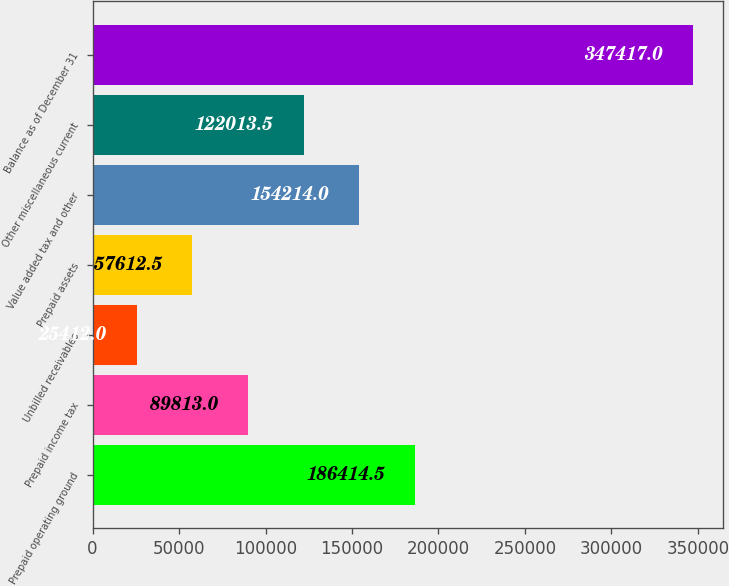Convert chart. <chart><loc_0><loc_0><loc_500><loc_500><bar_chart><fcel>Prepaid operating ground<fcel>Prepaid income tax<fcel>Unbilled receivables<fcel>Prepaid assets<fcel>Value added tax and other<fcel>Other miscellaneous current<fcel>Balance as of December 31<nl><fcel>186414<fcel>89813<fcel>25412<fcel>57612.5<fcel>154214<fcel>122014<fcel>347417<nl></chart> 